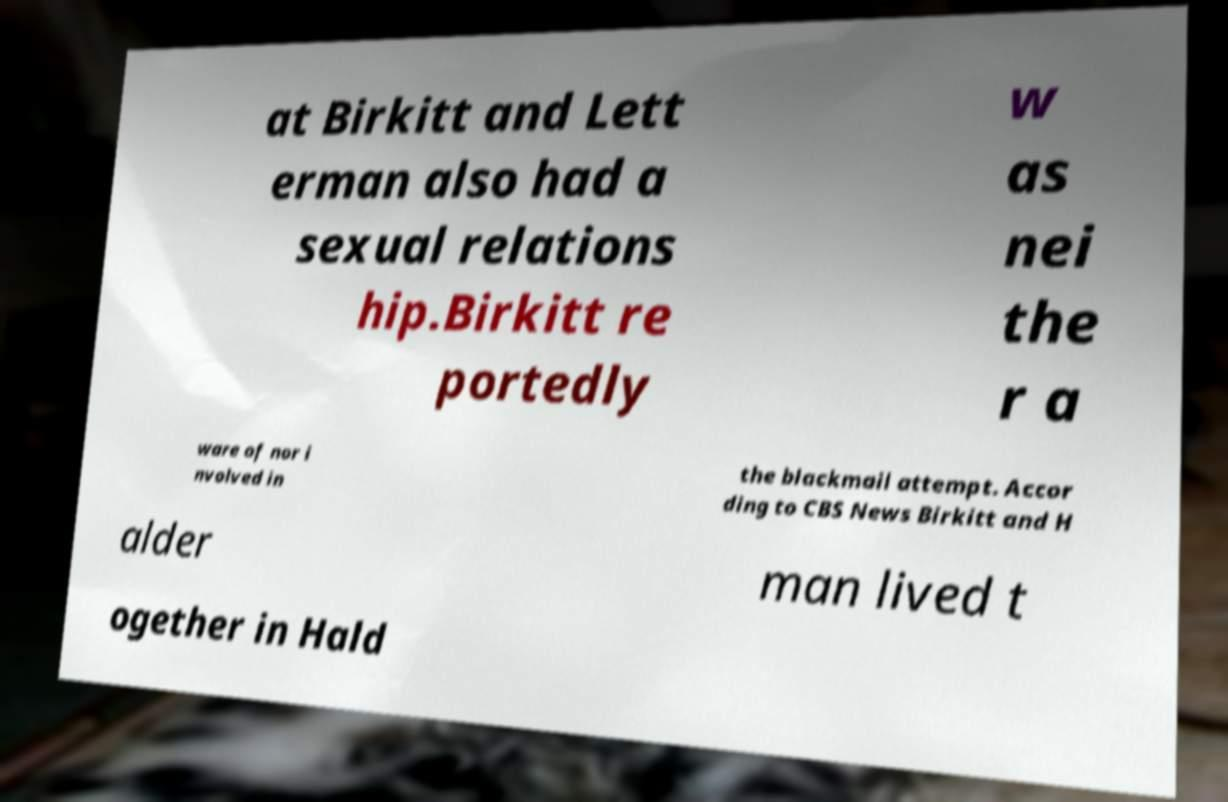Can you read and provide the text displayed in the image?This photo seems to have some interesting text. Can you extract and type it out for me? at Birkitt and Lett erman also had a sexual relations hip.Birkitt re portedly w as nei the r a ware of nor i nvolved in the blackmail attempt. Accor ding to CBS News Birkitt and H alder man lived t ogether in Hald 